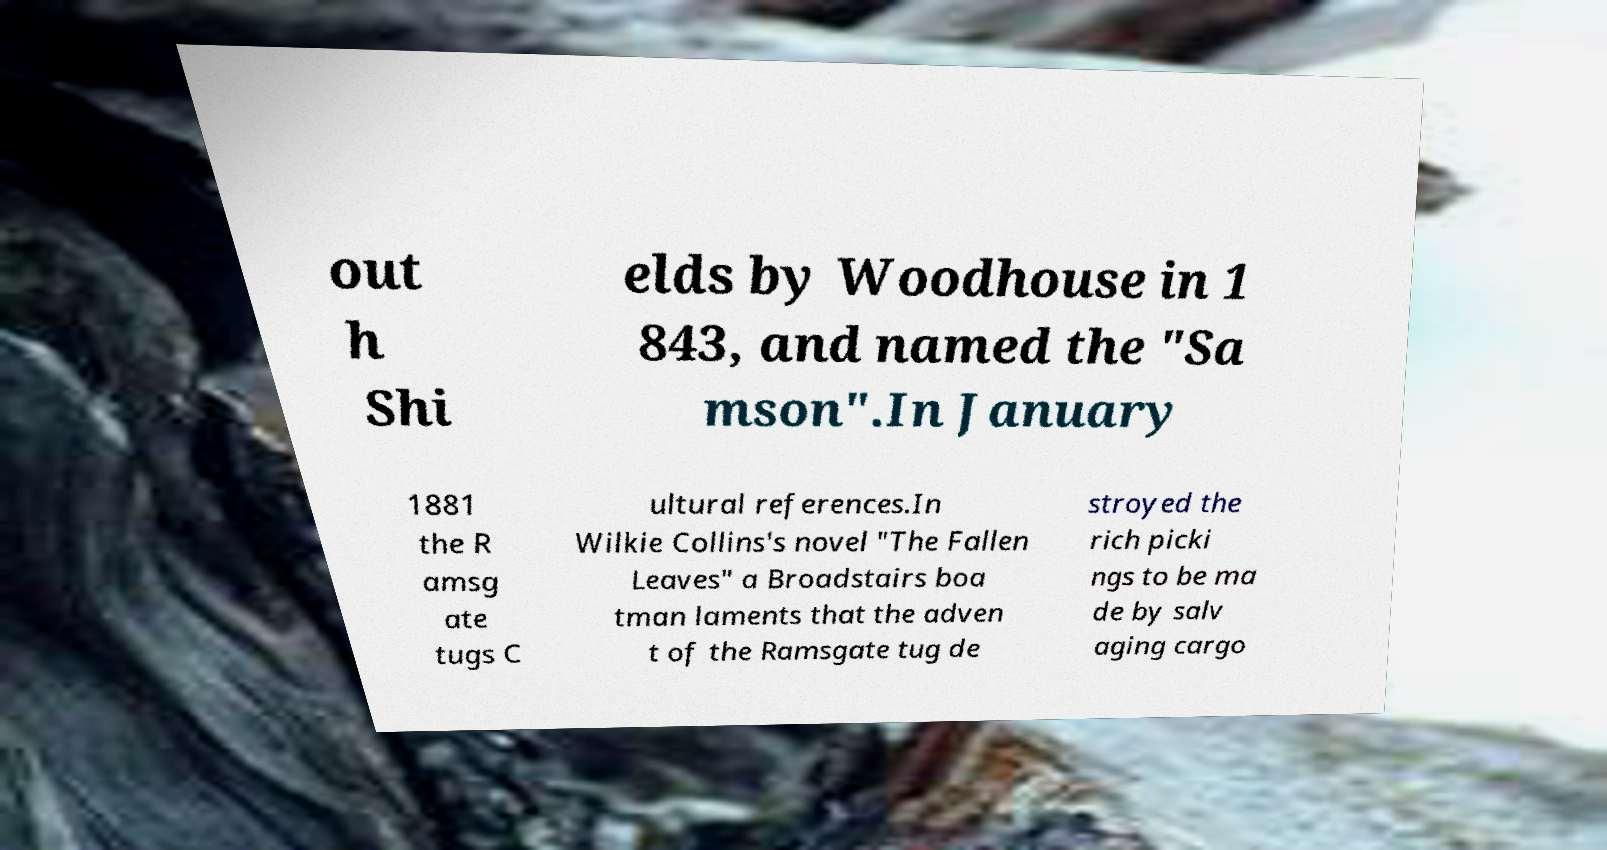Can you read and provide the text displayed in the image?This photo seems to have some interesting text. Can you extract and type it out for me? out h Shi elds by Woodhouse in 1 843, and named the "Sa mson".In January 1881 the R amsg ate tugs C ultural references.In Wilkie Collins's novel "The Fallen Leaves" a Broadstairs boa tman laments that the adven t of the Ramsgate tug de stroyed the rich picki ngs to be ma de by salv aging cargo 